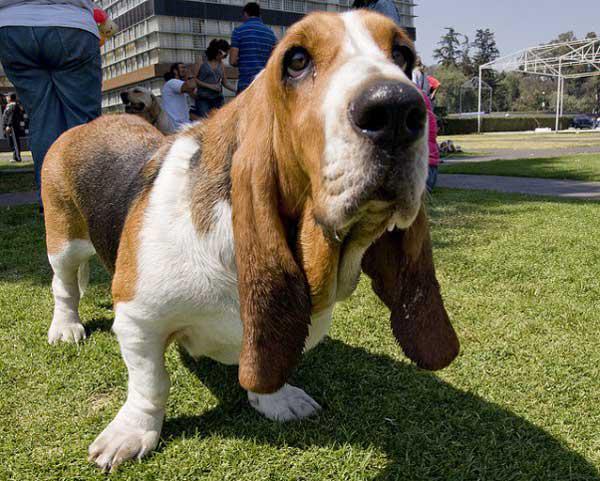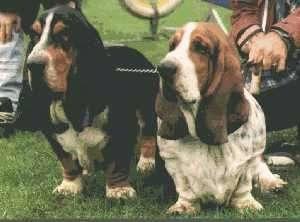The first image is the image on the left, the second image is the image on the right. Considering the images on both sides, is "A sitting basset hound is interacting with one smaller basset hound on the grass." valid? Answer yes or no. No. The first image is the image on the left, the second image is the image on the right. For the images shown, is this caption "A single dog is standing int he grass in one of the images." true? Answer yes or no. Yes. 